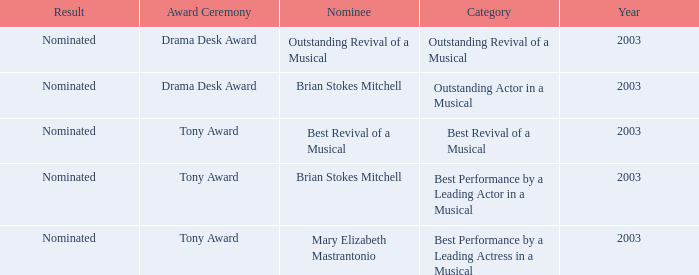What was the decision regarding the nomination for best revival of a musical? Nominated. 